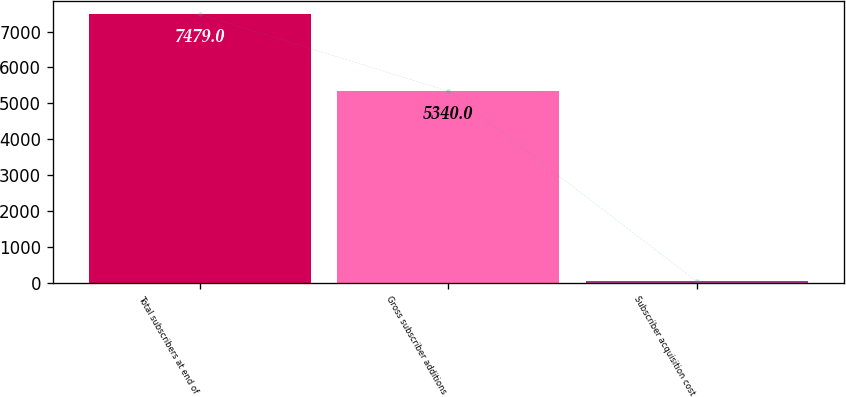Convert chart. <chart><loc_0><loc_0><loc_500><loc_500><bar_chart><fcel>Total subscribers at end of<fcel>Gross subscriber additions<fcel>Subscriber acquisition cost<nl><fcel>7479<fcel>5340<fcel>40.86<nl></chart> 